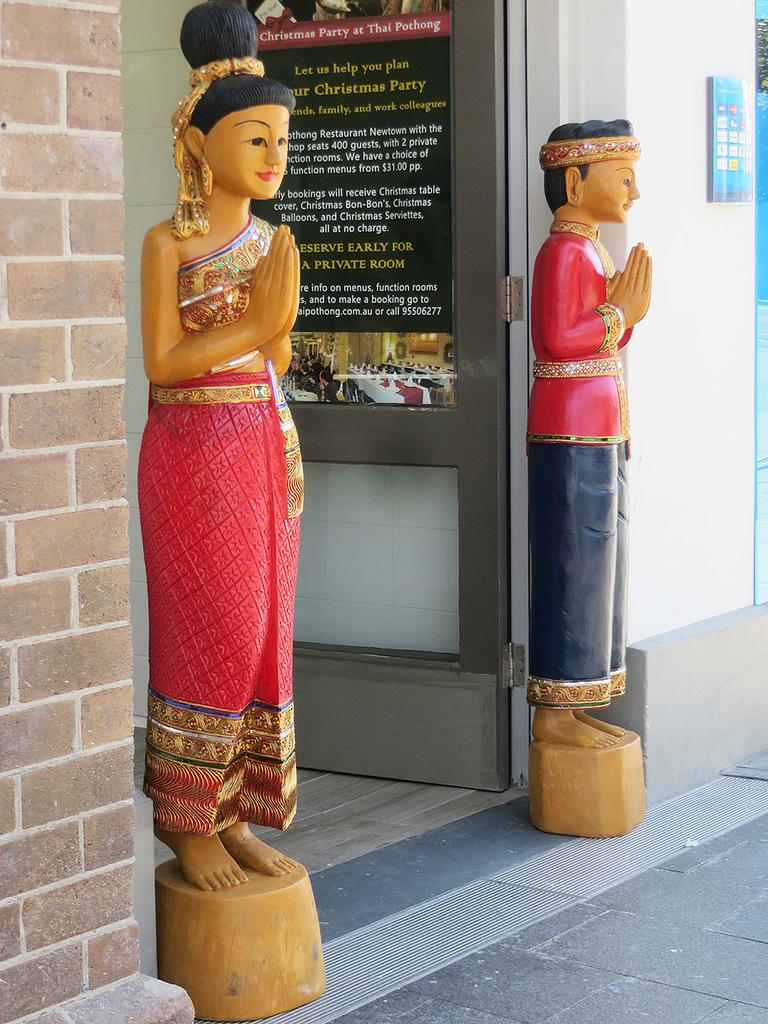How many sculptures can be seen in the image? There are two sculptures in the image. What else is present in the image besides the sculptures? There is a door in the image. Can you describe what is written on the door? Unfortunately, the specific text on the door cannot be determined from the image. What type of architectural feature is visible in the image? There is a wall in the image. What type of vase is placed on the floor next to the sculptures? There is no vase present in the image; only the two sculptures, a door, and a wall are visible. 